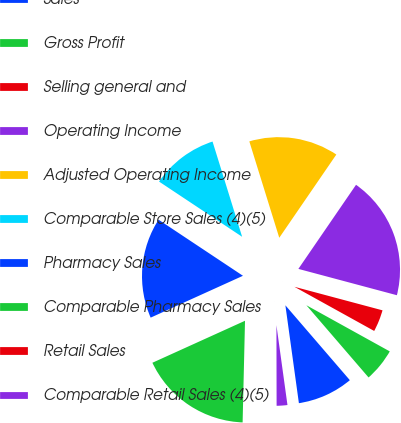<chart> <loc_0><loc_0><loc_500><loc_500><pie_chart><fcel>Sales<fcel>Gross Profit<fcel>Selling general and<fcel>Operating Income<fcel>Adjusted Operating Income<fcel>Comparable Store Sales (4)(5)<fcel>Pharmacy Sales<fcel>Comparable Pharmacy Sales<fcel>Retail Sales<fcel>Comparable Retail Sales (4)(5)<nl><fcel>9.13%<fcel>5.64%<fcel>3.89%<fcel>19.59%<fcel>14.36%<fcel>10.87%<fcel>16.11%<fcel>17.85%<fcel>0.41%<fcel>2.15%<nl></chart> 